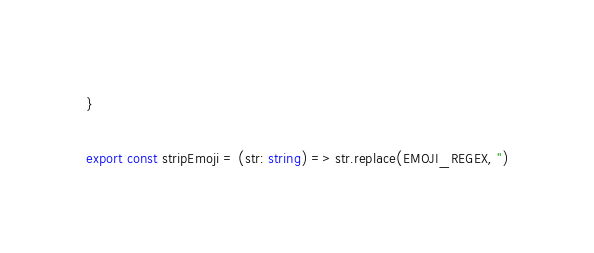<code> <loc_0><loc_0><loc_500><loc_500><_TypeScript_>}

export const stripEmoji = (str: string) => str.replace(EMOJI_REGEX, '')
</code> 